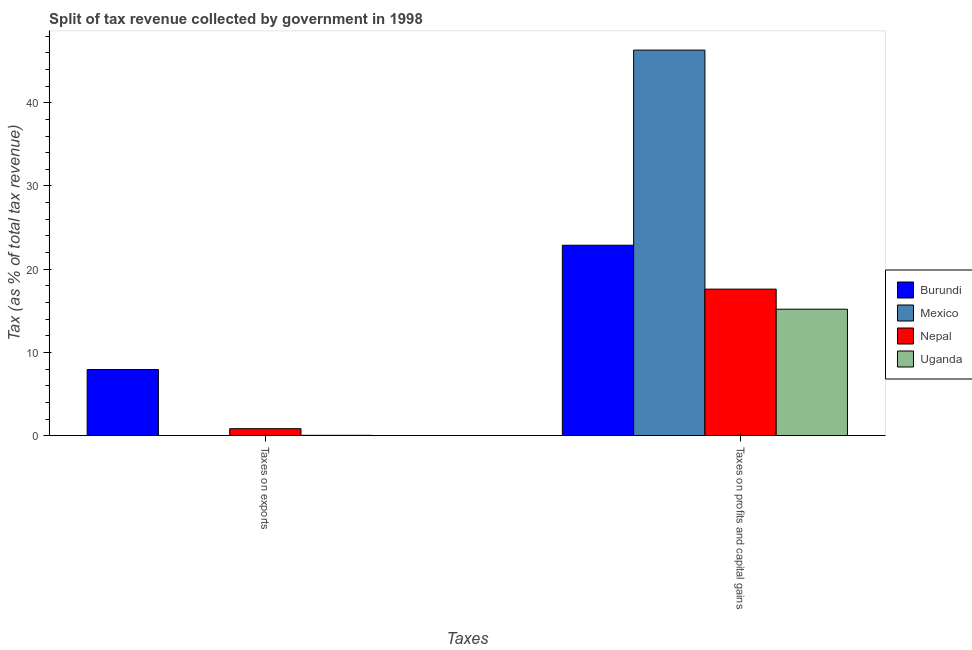How many different coloured bars are there?
Offer a very short reply. 4. How many groups of bars are there?
Make the answer very short. 2. How many bars are there on the 1st tick from the left?
Make the answer very short. 4. How many bars are there on the 2nd tick from the right?
Give a very brief answer. 4. What is the label of the 2nd group of bars from the left?
Provide a short and direct response. Taxes on profits and capital gains. What is the percentage of revenue obtained from taxes on profits and capital gains in Burundi?
Ensure brevity in your answer.  22.88. Across all countries, what is the maximum percentage of revenue obtained from taxes on exports?
Provide a short and direct response. 7.94. Across all countries, what is the minimum percentage of revenue obtained from taxes on exports?
Give a very brief answer. 0. In which country was the percentage of revenue obtained from taxes on exports maximum?
Offer a terse response. Burundi. In which country was the percentage of revenue obtained from taxes on profits and capital gains minimum?
Offer a terse response. Uganda. What is the total percentage of revenue obtained from taxes on exports in the graph?
Your response must be concise. 8.82. What is the difference between the percentage of revenue obtained from taxes on profits and capital gains in Mexico and that in Uganda?
Ensure brevity in your answer.  31.14. What is the difference between the percentage of revenue obtained from taxes on profits and capital gains in Mexico and the percentage of revenue obtained from taxes on exports in Burundi?
Provide a short and direct response. 38.38. What is the average percentage of revenue obtained from taxes on profits and capital gains per country?
Keep it short and to the point. 25.5. What is the difference between the percentage of revenue obtained from taxes on exports and percentage of revenue obtained from taxes on profits and capital gains in Burundi?
Offer a very short reply. -14.94. In how many countries, is the percentage of revenue obtained from taxes on profits and capital gains greater than 8 %?
Your answer should be very brief. 4. What is the ratio of the percentage of revenue obtained from taxes on exports in Nepal to that in Mexico?
Your answer should be very brief. 3275.29. Is the percentage of revenue obtained from taxes on profits and capital gains in Burundi less than that in Uganda?
Give a very brief answer. No. What does the 2nd bar from the left in Taxes on exports represents?
Offer a very short reply. Mexico. What does the 2nd bar from the right in Taxes on profits and capital gains represents?
Make the answer very short. Nepal. How many bars are there?
Offer a terse response. 8. What is the difference between two consecutive major ticks on the Y-axis?
Give a very brief answer. 10. Does the graph contain any zero values?
Provide a succinct answer. No. Does the graph contain grids?
Your answer should be very brief. No. Where does the legend appear in the graph?
Provide a short and direct response. Center right. How many legend labels are there?
Your response must be concise. 4. How are the legend labels stacked?
Offer a terse response. Vertical. What is the title of the graph?
Offer a terse response. Split of tax revenue collected by government in 1998. Does "Bangladesh" appear as one of the legend labels in the graph?
Offer a terse response. No. What is the label or title of the X-axis?
Give a very brief answer. Taxes. What is the label or title of the Y-axis?
Give a very brief answer. Tax (as % of total tax revenue). What is the Tax (as % of total tax revenue) of Burundi in Taxes on exports?
Your answer should be compact. 7.94. What is the Tax (as % of total tax revenue) in Mexico in Taxes on exports?
Provide a short and direct response. 0. What is the Tax (as % of total tax revenue) of Nepal in Taxes on exports?
Provide a short and direct response. 0.83. What is the Tax (as % of total tax revenue) in Uganda in Taxes on exports?
Give a very brief answer. 0.04. What is the Tax (as % of total tax revenue) of Burundi in Taxes on profits and capital gains?
Ensure brevity in your answer.  22.88. What is the Tax (as % of total tax revenue) in Mexico in Taxes on profits and capital gains?
Provide a short and direct response. 46.33. What is the Tax (as % of total tax revenue) of Nepal in Taxes on profits and capital gains?
Provide a short and direct response. 17.61. What is the Tax (as % of total tax revenue) in Uganda in Taxes on profits and capital gains?
Make the answer very short. 15.19. Across all Taxes, what is the maximum Tax (as % of total tax revenue) of Burundi?
Your answer should be very brief. 22.88. Across all Taxes, what is the maximum Tax (as % of total tax revenue) of Mexico?
Your answer should be very brief. 46.33. Across all Taxes, what is the maximum Tax (as % of total tax revenue) in Nepal?
Your response must be concise. 17.61. Across all Taxes, what is the maximum Tax (as % of total tax revenue) of Uganda?
Provide a short and direct response. 15.19. Across all Taxes, what is the minimum Tax (as % of total tax revenue) in Burundi?
Give a very brief answer. 7.94. Across all Taxes, what is the minimum Tax (as % of total tax revenue) in Mexico?
Offer a terse response. 0. Across all Taxes, what is the minimum Tax (as % of total tax revenue) of Nepal?
Make the answer very short. 0.83. Across all Taxes, what is the minimum Tax (as % of total tax revenue) in Uganda?
Make the answer very short. 0.04. What is the total Tax (as % of total tax revenue) of Burundi in the graph?
Provide a succinct answer. 30.83. What is the total Tax (as % of total tax revenue) in Mexico in the graph?
Offer a terse response. 46.33. What is the total Tax (as % of total tax revenue) in Nepal in the graph?
Your answer should be very brief. 18.44. What is the total Tax (as % of total tax revenue) of Uganda in the graph?
Ensure brevity in your answer.  15.23. What is the difference between the Tax (as % of total tax revenue) in Burundi in Taxes on exports and that in Taxes on profits and capital gains?
Make the answer very short. -14.94. What is the difference between the Tax (as % of total tax revenue) of Mexico in Taxes on exports and that in Taxes on profits and capital gains?
Ensure brevity in your answer.  -46.33. What is the difference between the Tax (as % of total tax revenue) of Nepal in Taxes on exports and that in Taxes on profits and capital gains?
Ensure brevity in your answer.  -16.77. What is the difference between the Tax (as % of total tax revenue) in Uganda in Taxes on exports and that in Taxes on profits and capital gains?
Offer a very short reply. -15.15. What is the difference between the Tax (as % of total tax revenue) of Burundi in Taxes on exports and the Tax (as % of total tax revenue) of Mexico in Taxes on profits and capital gains?
Make the answer very short. -38.38. What is the difference between the Tax (as % of total tax revenue) in Burundi in Taxes on exports and the Tax (as % of total tax revenue) in Nepal in Taxes on profits and capital gains?
Provide a succinct answer. -9.66. What is the difference between the Tax (as % of total tax revenue) in Burundi in Taxes on exports and the Tax (as % of total tax revenue) in Uganda in Taxes on profits and capital gains?
Ensure brevity in your answer.  -7.25. What is the difference between the Tax (as % of total tax revenue) of Mexico in Taxes on exports and the Tax (as % of total tax revenue) of Nepal in Taxes on profits and capital gains?
Ensure brevity in your answer.  -17.61. What is the difference between the Tax (as % of total tax revenue) of Mexico in Taxes on exports and the Tax (as % of total tax revenue) of Uganda in Taxes on profits and capital gains?
Keep it short and to the point. -15.19. What is the difference between the Tax (as % of total tax revenue) of Nepal in Taxes on exports and the Tax (as % of total tax revenue) of Uganda in Taxes on profits and capital gains?
Ensure brevity in your answer.  -14.36. What is the average Tax (as % of total tax revenue) in Burundi per Taxes?
Provide a short and direct response. 15.41. What is the average Tax (as % of total tax revenue) of Mexico per Taxes?
Ensure brevity in your answer.  23.16. What is the average Tax (as % of total tax revenue) in Nepal per Taxes?
Offer a terse response. 9.22. What is the average Tax (as % of total tax revenue) in Uganda per Taxes?
Keep it short and to the point. 7.62. What is the difference between the Tax (as % of total tax revenue) of Burundi and Tax (as % of total tax revenue) of Mexico in Taxes on exports?
Offer a terse response. 7.94. What is the difference between the Tax (as % of total tax revenue) in Burundi and Tax (as % of total tax revenue) in Nepal in Taxes on exports?
Make the answer very short. 7.11. What is the difference between the Tax (as % of total tax revenue) of Burundi and Tax (as % of total tax revenue) of Uganda in Taxes on exports?
Your response must be concise. 7.91. What is the difference between the Tax (as % of total tax revenue) of Mexico and Tax (as % of total tax revenue) of Nepal in Taxes on exports?
Ensure brevity in your answer.  -0.83. What is the difference between the Tax (as % of total tax revenue) in Mexico and Tax (as % of total tax revenue) in Uganda in Taxes on exports?
Provide a succinct answer. -0.04. What is the difference between the Tax (as % of total tax revenue) of Nepal and Tax (as % of total tax revenue) of Uganda in Taxes on exports?
Provide a short and direct response. 0.8. What is the difference between the Tax (as % of total tax revenue) of Burundi and Tax (as % of total tax revenue) of Mexico in Taxes on profits and capital gains?
Offer a very short reply. -23.45. What is the difference between the Tax (as % of total tax revenue) of Burundi and Tax (as % of total tax revenue) of Nepal in Taxes on profits and capital gains?
Provide a short and direct response. 5.28. What is the difference between the Tax (as % of total tax revenue) in Burundi and Tax (as % of total tax revenue) in Uganda in Taxes on profits and capital gains?
Your answer should be very brief. 7.69. What is the difference between the Tax (as % of total tax revenue) in Mexico and Tax (as % of total tax revenue) in Nepal in Taxes on profits and capital gains?
Offer a very short reply. 28.72. What is the difference between the Tax (as % of total tax revenue) of Mexico and Tax (as % of total tax revenue) of Uganda in Taxes on profits and capital gains?
Your answer should be compact. 31.14. What is the difference between the Tax (as % of total tax revenue) of Nepal and Tax (as % of total tax revenue) of Uganda in Taxes on profits and capital gains?
Your answer should be very brief. 2.41. What is the ratio of the Tax (as % of total tax revenue) of Burundi in Taxes on exports to that in Taxes on profits and capital gains?
Provide a short and direct response. 0.35. What is the ratio of the Tax (as % of total tax revenue) of Mexico in Taxes on exports to that in Taxes on profits and capital gains?
Offer a very short reply. 0. What is the ratio of the Tax (as % of total tax revenue) of Nepal in Taxes on exports to that in Taxes on profits and capital gains?
Your answer should be very brief. 0.05. What is the ratio of the Tax (as % of total tax revenue) of Uganda in Taxes on exports to that in Taxes on profits and capital gains?
Ensure brevity in your answer.  0. What is the difference between the highest and the second highest Tax (as % of total tax revenue) of Burundi?
Offer a very short reply. 14.94. What is the difference between the highest and the second highest Tax (as % of total tax revenue) of Mexico?
Provide a short and direct response. 46.33. What is the difference between the highest and the second highest Tax (as % of total tax revenue) in Nepal?
Your answer should be very brief. 16.77. What is the difference between the highest and the second highest Tax (as % of total tax revenue) in Uganda?
Your response must be concise. 15.15. What is the difference between the highest and the lowest Tax (as % of total tax revenue) in Burundi?
Give a very brief answer. 14.94. What is the difference between the highest and the lowest Tax (as % of total tax revenue) of Mexico?
Your answer should be compact. 46.33. What is the difference between the highest and the lowest Tax (as % of total tax revenue) in Nepal?
Ensure brevity in your answer.  16.77. What is the difference between the highest and the lowest Tax (as % of total tax revenue) in Uganda?
Provide a short and direct response. 15.15. 